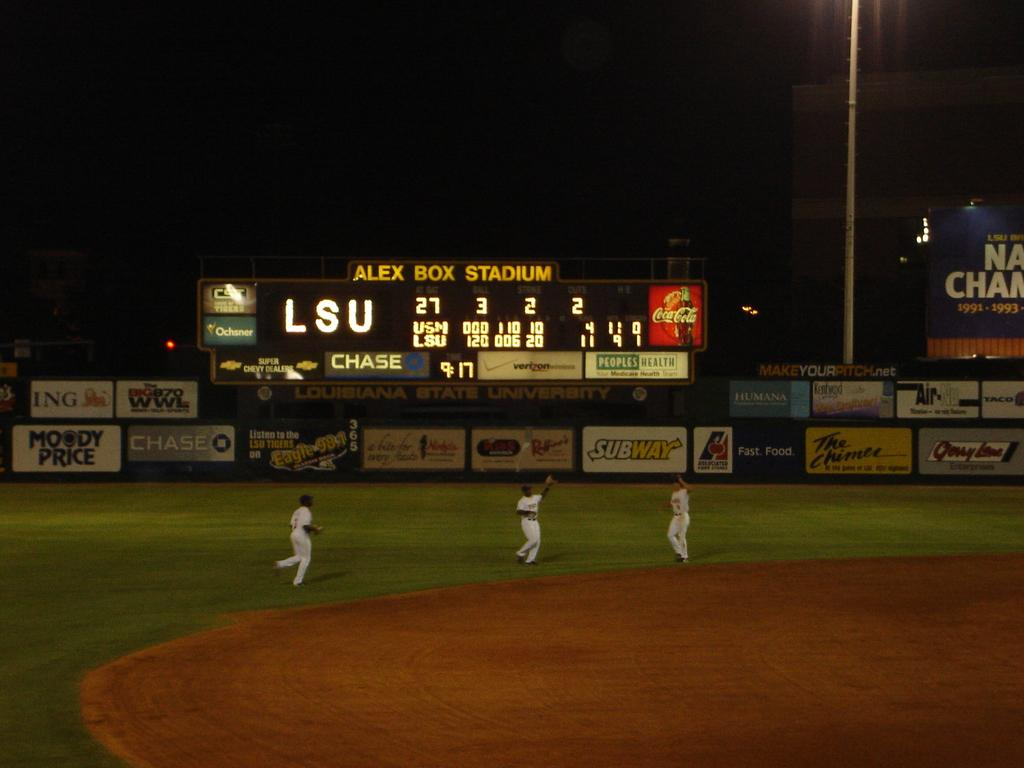<image>
Provide a brief description of the given image. A scoreboard at Alex Box Stadium for a baseball game. 